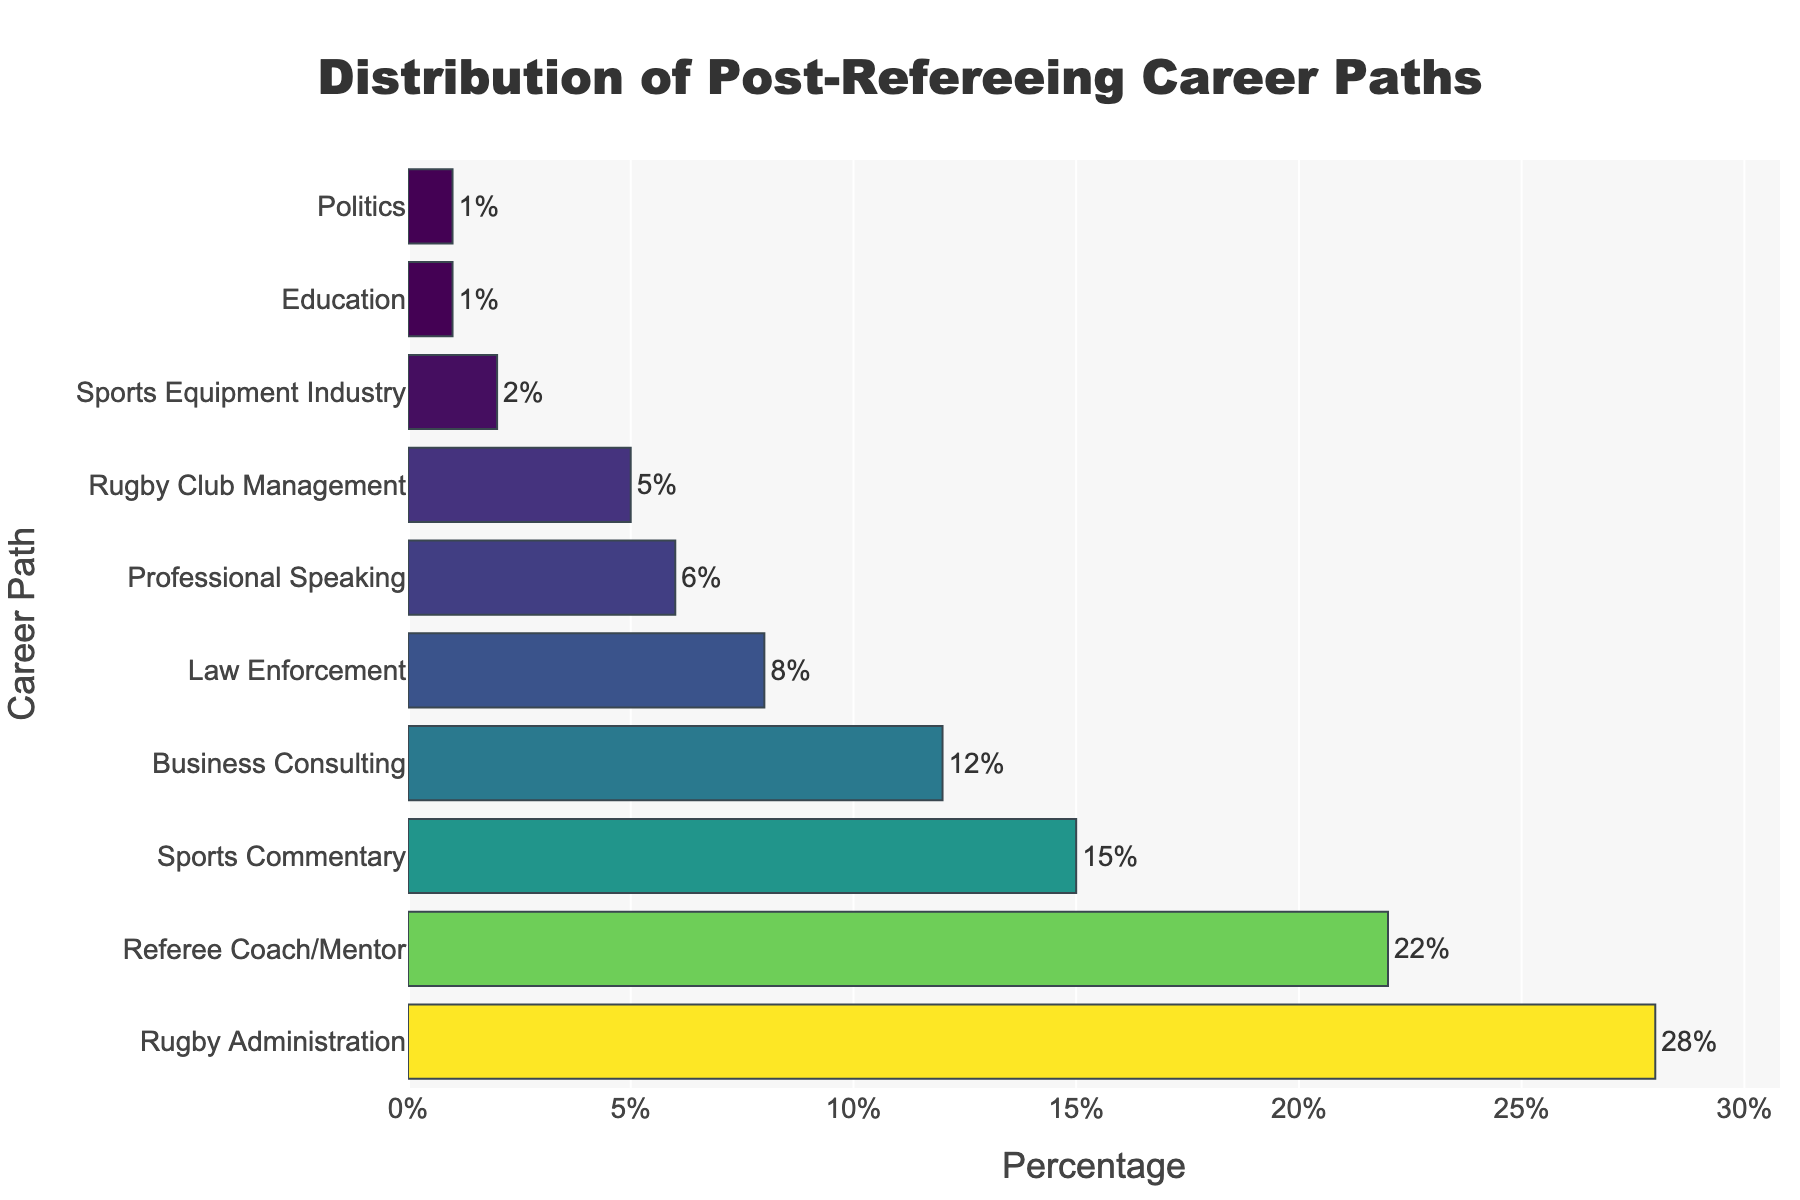What is the most common post-refereeing career path for former top-level rugby referees? The highest bar in the graph represents the most common career path. The "Rugby Administration" bar has the largest value at 28%.
Answer: Rugby Administration Which career path has a higher percentage: Referee Coach/Mentor or Business Consulting? To determine which has a higher percentage, compare the lengths of the bars for "Referee Coach/Mentor" and "Business Consulting". Referee Coach/Mentor is 22%, and Business Consulting is 12%.
Answer: Referee Coach/Mentor What is the combined percentage of referees taking up roles in Law Enforcement and Politics? Summing up the percentages for "Law Enforcement" (8%) and "Politics" (1%) gives us the combined percentage: 8% + 1% = 9%.
Answer: 9% Between Rugby Club Management and Sports Commentary, which career path is less common? Compare the lengths of the bars for "Rugby Club Management" and "Sports Commentary". Rugby Club Management is at 5%, and Sports Commentary is at 15%.
Answer: Rugby Club Management What is the difference in percentage between the most common and least common post-refereeing career paths? Subtract the percentage of the least common career path (Politics, 1%) from the most common career path (Rugby Administration, 28%): 28% - 1% = 27%.
Answer: 27% If we combine the percentages of Education, Politics, and Sports Equipment Industry, what is their total? Sum the percentages of "Education" (1%), "Politics" (1%), and "Sports Equipment Industry" (2%): 1% + 1% + 2% = 4%.
Answer: 4% Which career path's bar is exactly 6% in the chart? Refer to the length of the bar labeled as 6%. The "Professional Speaking" bar is at 6%.
Answer: Professional Speaking What is the average percentage for the top three most common post-refereeing career paths? Add the percentages of the top three career paths: Rugby Administration (28%), Referee Coach/Mentor (22%), and Sports Commentary (15%), then divide by 3: (28% + 22% + 15%) / 3 = 65% / 3 ≈ 21.67%.
Answer: 21.67% Compare Business Consulting and Education in terms of their career path percentages. Which has a higher percentage and by how much? Compare the lengths of the bars for "Business Consulting" (12%) and "Education" (1%). Calculate the difference: 12% - 1% = 11%.
Answer: Business Consulting by 11% 